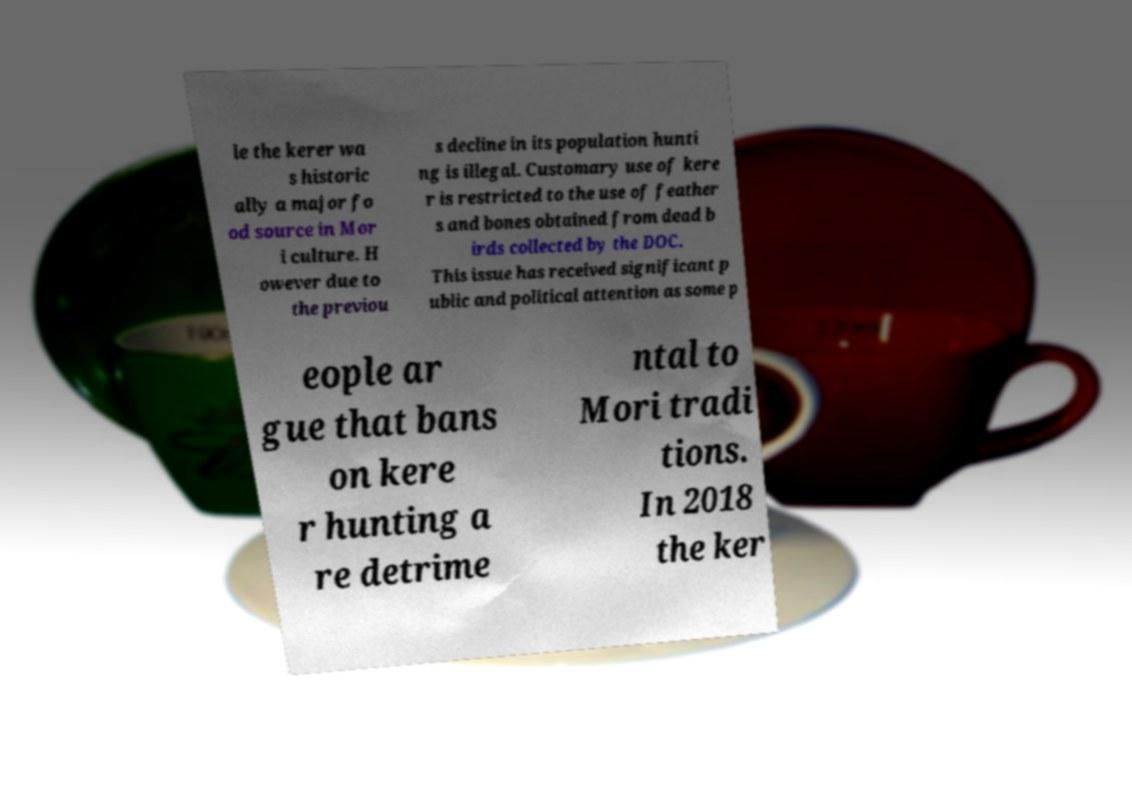Could you assist in decoding the text presented in this image and type it out clearly? le the kerer wa s historic ally a major fo od source in Mor i culture. H owever due to the previou s decline in its population hunti ng is illegal. Customary use of kere r is restricted to the use of feather s and bones obtained from dead b irds collected by the DOC. This issue has received significant p ublic and political attention as some p eople ar gue that bans on kere r hunting a re detrime ntal to Mori tradi tions. In 2018 the ker 